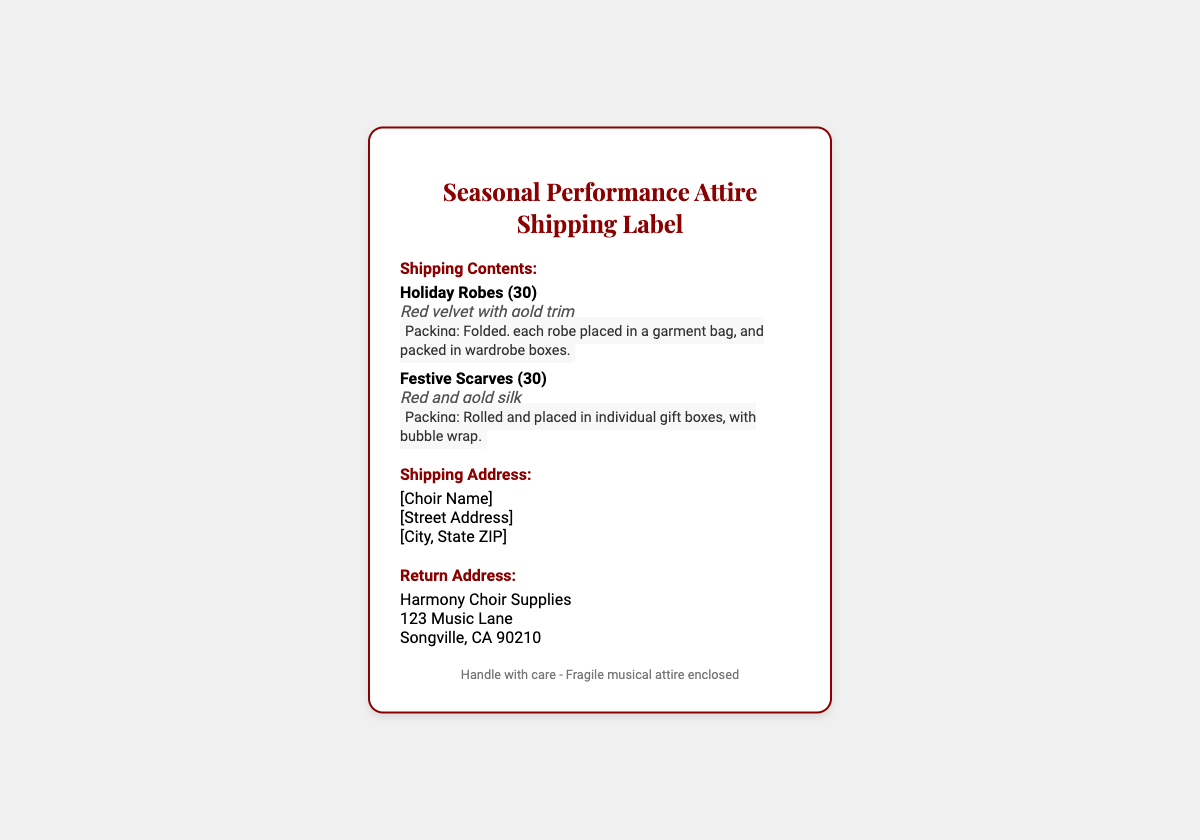What is the title of the document? The title of the document is prominently displayed at the top of the shipping label.
Answer: Seasonal Performance Attire Shipping Label How many holiday robes are included in the shipment? The number of holiday robes can be found in the shipping contents section listed with the item name.
Answer: 30 What color are the holiday robes? The color of the holiday robes is specified in the item details section.
Answer: Red velvet How are the festive scarves packed? The packing instructions describe how the festive scarves are packaged for shipping.
Answer: Rolled and placed in individual gift boxes, with bubble wrap Who is the return address sender? The return address sender is provided in its designated section of the document.
Answer: Harmony Choir Supplies What type of scarf is included in the shipment? The type of scarf is detailed in the shipping contents section with the item name and description.
Answer: Festive Scarves What is the packing method for holiday robes? The packing method for holiday robes is listed under packing instructions in the shipping contents.
Answer: Folded, each robe placed in a garment bag, and packed in wardrobe boxes What is the shipping address placeholder indication? The shipping address indicates placeholders for specific details that need to be filled in.
Answer: [Choir Name] What should be noted during handling of the package? The footer provides important handling instructions for the contents of the package.
Answer: Handle with care - Fragile musical attire enclosed 